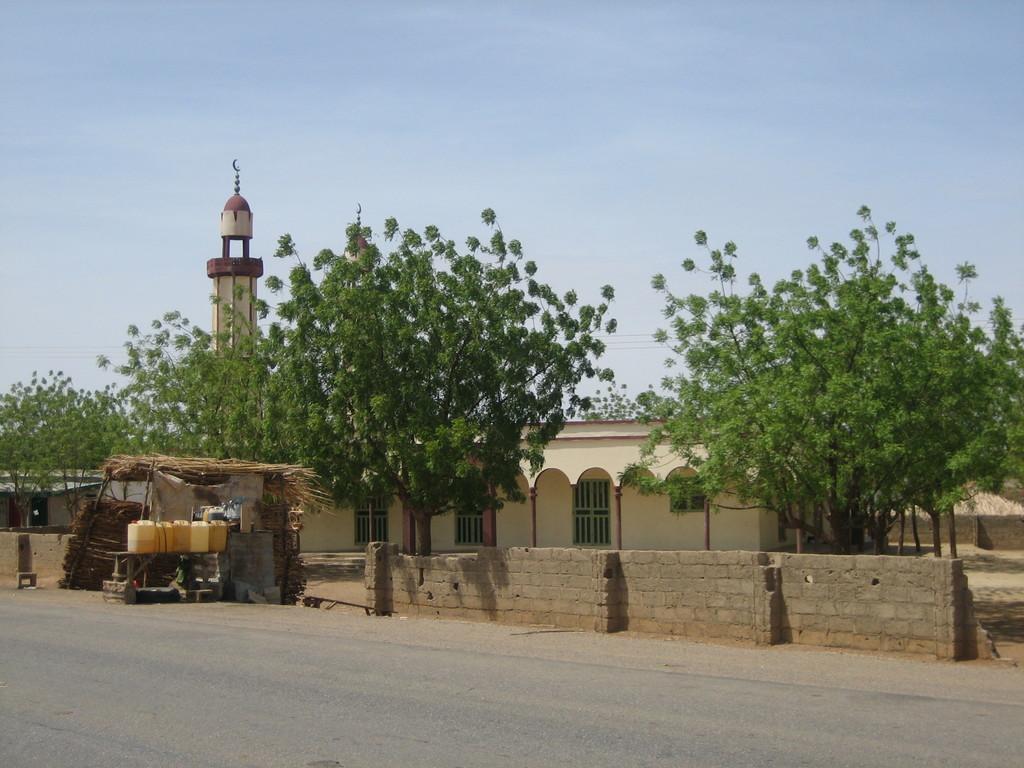In one or two sentences, can you explain what this image depicts? In this picture we can see the road, here we can see cans, hut, wall and some objects and in the background we can see a building, house, trees and the sky. 